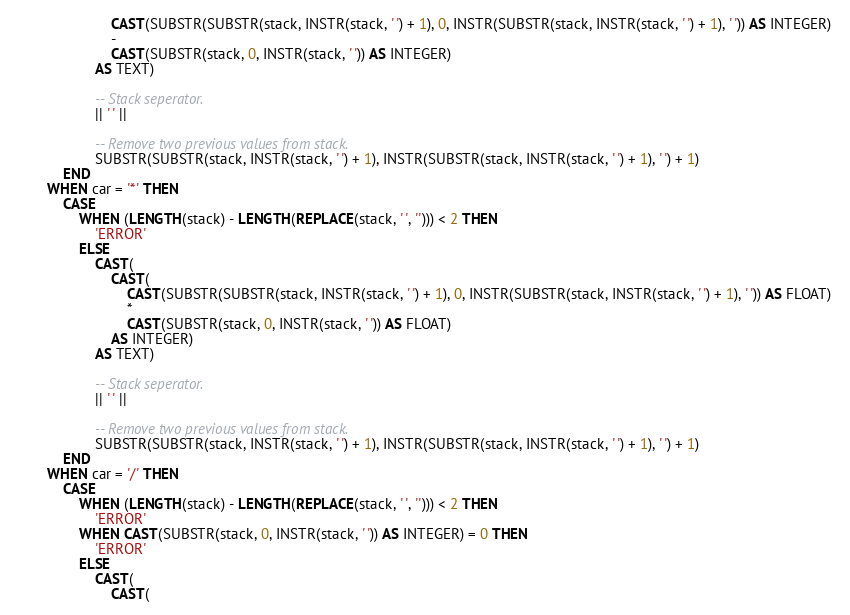Convert code to text. <code><loc_0><loc_0><loc_500><loc_500><_SQL_>                        CAST(SUBSTR(SUBSTR(stack, INSTR(stack, ' ') + 1), 0, INSTR(SUBSTR(stack, INSTR(stack, ' ') + 1), ' ')) AS INTEGER) 
                        - 
                        CAST(SUBSTR(stack, 0, INSTR(stack, ' ')) AS INTEGER)
                    AS TEXT) 
                    
                    -- Stack seperator.
                    || ' ' ||
                    
                    -- Remove two previous values from stack.
                    SUBSTR(SUBSTR(stack, INSTR(stack, ' ') + 1), INSTR(SUBSTR(stack, INSTR(stack, ' ') + 1), ' ') + 1)
            END
        WHEN car = '*' THEN
			CASE
                WHEN (LENGTH(stack) - LENGTH(REPLACE(stack, ' ', ''))) < 2 THEN 
                    'ERROR'
                ELSE
                    CAST(
                        CAST(
                            CAST(SUBSTR(SUBSTR(stack, INSTR(stack, ' ') + 1), 0, INSTR(SUBSTR(stack, INSTR(stack, ' ') + 1), ' ')) AS FLOAT) 
                            *
                            CAST(SUBSTR(stack, 0, INSTR(stack, ' ')) AS FLOAT)
                        AS INTEGER) 
                    AS TEXT) 
                    
                    -- Stack seperator.
                    || ' ' ||
                    
                    -- Remove two previous values from stack.
                    SUBSTR(SUBSTR(stack, INSTR(stack, ' ') + 1), INSTR(SUBSTR(stack, INSTR(stack, ' ') + 1), ' ') + 1)
            END
        WHEN car = '/' THEN
			CASE
                WHEN (LENGTH(stack) - LENGTH(REPLACE(stack, ' ', ''))) < 2 THEN 
                    'ERROR'
                WHEN CAST(SUBSTR(stack, 0, INSTR(stack, ' ')) AS INTEGER) = 0 THEN 
                    'ERROR'
                ELSE
                    CAST(
                        CAST(</code> 